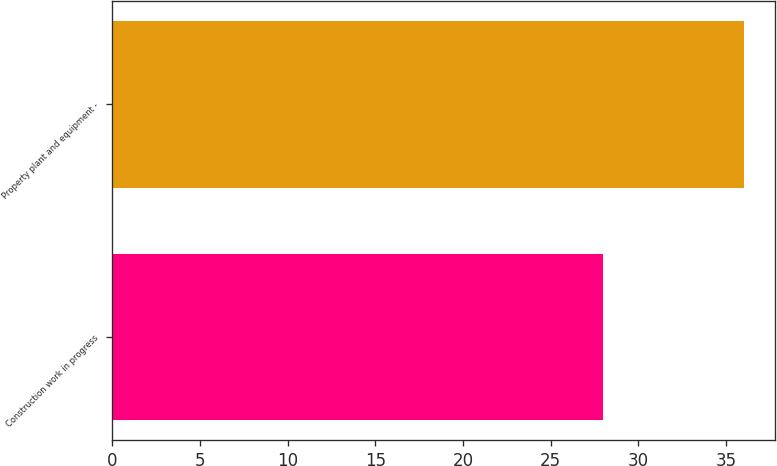Convert chart to OTSL. <chart><loc_0><loc_0><loc_500><loc_500><bar_chart><fcel>Construction work in progress<fcel>Property plant and equipment -<nl><fcel>28<fcel>36<nl></chart> 